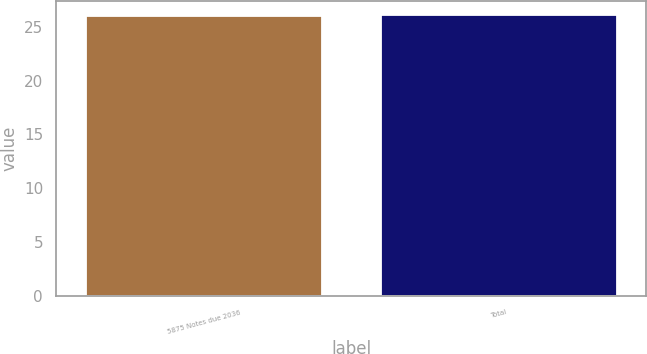Convert chart to OTSL. <chart><loc_0><loc_0><loc_500><loc_500><bar_chart><fcel>5875 Notes due 2036<fcel>Total<nl><fcel>26<fcel>26.1<nl></chart> 